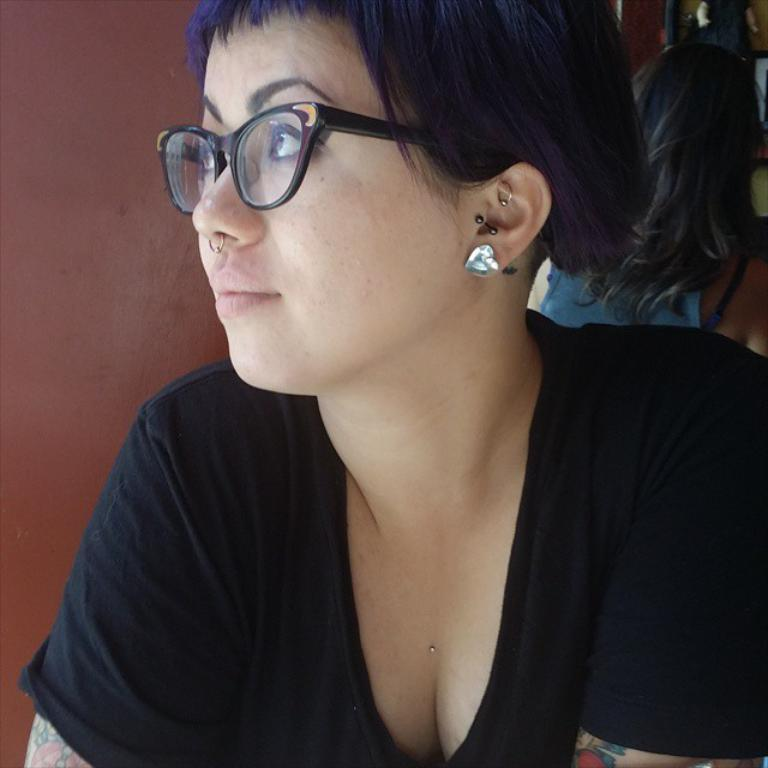Who is present in the image? There is a woman in the image. What is the woman doing in the image? The woman is sitting. Can you describe any distinguishing features of the woman? The woman has a piercing ring in her nose. What type of engine can be seen in the background of the image? There is no engine present in the image; it only features a woman sitting with a piercing ring in her nose. 